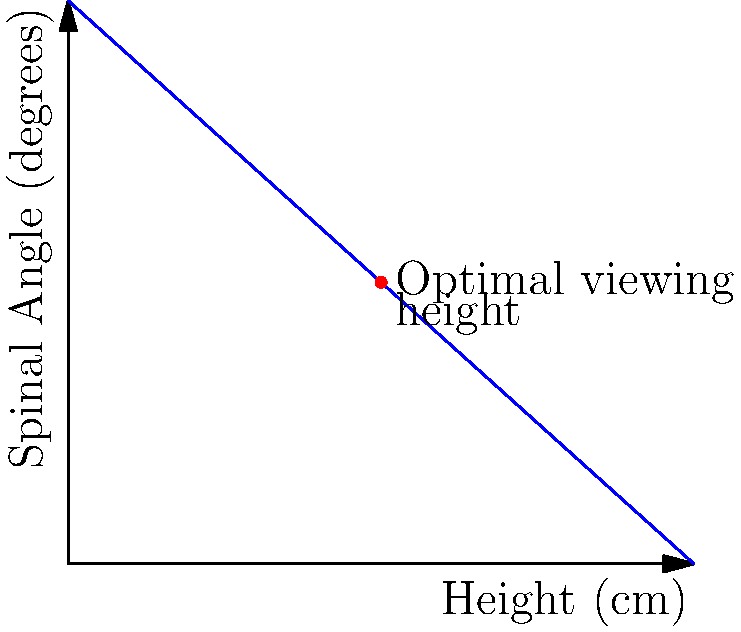As a PR representative for refurbished 1960s jukeboxes, you're concerned about customer comfort while browsing song titles. The graph shows the relationship between jukebox height and a person's spinal angle when bending to read titles. At what height (in cm) does the graph indicate optimal viewing comfort, and what is the corresponding spinal angle? To determine the optimal viewing height and corresponding spinal angle:

1. Observe the graph: it shows a negative linear relationship between jukebox height and spinal angle.

2. The optimal viewing position is typically where the spine is at a comfortable angle, neither too upright nor too bent.

3. On the graph, this optimal point is marked with a red dot.

4. To find the height:
   - Trace a vertical line from the red dot to the x-axis.
   - This intersects at 50 cm.

5. To find the spinal angle:
   - Trace a horizontal line from the red dot to the y-axis.
   - This intersects at 45 degrees.

6. The relationship can be expressed mathematically as:
   $$ \text{Spinal Angle} = 90 - 0.9 \times \text{Height} $$

7. At the optimal point: $45 = 90 - 0.9 \times 50$

Therefore, the optimal viewing height is 50 cm, with a corresponding spinal angle of 45 degrees.
Answer: 50 cm height, 45° spinal angle 